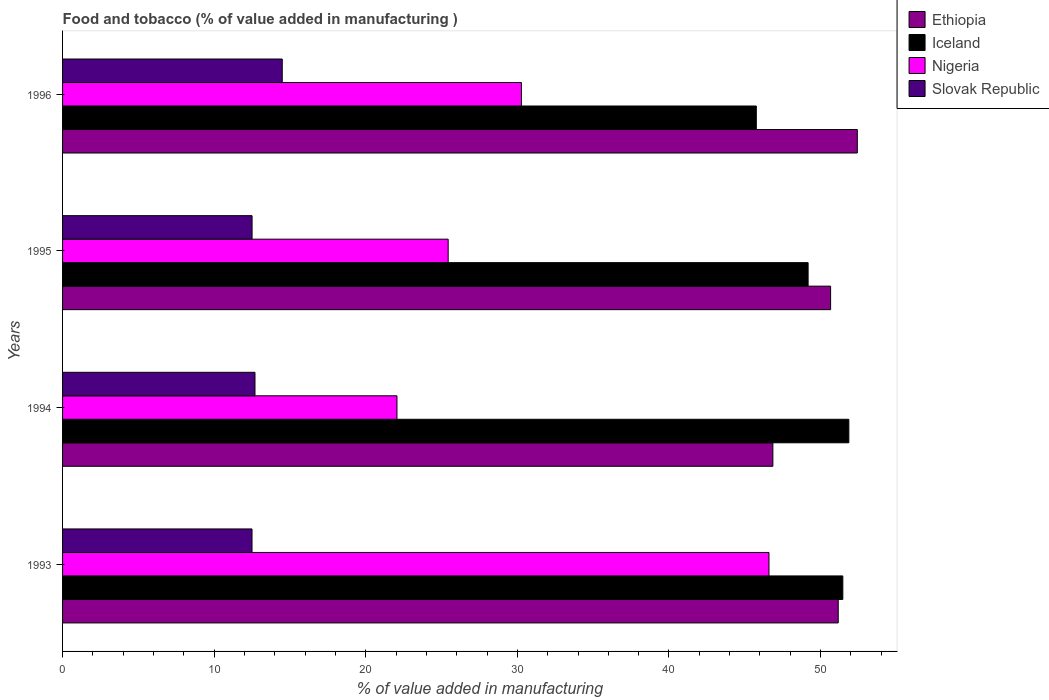How many different coloured bars are there?
Ensure brevity in your answer.  4. Are the number of bars per tick equal to the number of legend labels?
Offer a terse response. Yes. Are the number of bars on each tick of the Y-axis equal?
Keep it short and to the point. Yes. In how many cases, is the number of bars for a given year not equal to the number of legend labels?
Your answer should be compact. 0. What is the value added in manufacturing food and tobacco in Iceland in 1995?
Your answer should be compact. 49.18. Across all years, what is the maximum value added in manufacturing food and tobacco in Slovak Republic?
Provide a short and direct response. 14.49. Across all years, what is the minimum value added in manufacturing food and tobacco in Slovak Republic?
Offer a terse response. 12.5. In which year was the value added in manufacturing food and tobacco in Iceland maximum?
Ensure brevity in your answer.  1994. In which year was the value added in manufacturing food and tobacco in Iceland minimum?
Make the answer very short. 1996. What is the total value added in manufacturing food and tobacco in Nigeria in the graph?
Your answer should be compact. 124.35. What is the difference between the value added in manufacturing food and tobacco in Iceland in 1993 and that in 1996?
Offer a very short reply. 5.71. What is the difference between the value added in manufacturing food and tobacco in Nigeria in 1993 and the value added in manufacturing food and tobacco in Iceland in 1995?
Your answer should be compact. -2.58. What is the average value added in manufacturing food and tobacco in Ethiopia per year?
Your response must be concise. 50.27. In the year 1994, what is the difference between the value added in manufacturing food and tobacco in Nigeria and value added in manufacturing food and tobacco in Ethiopia?
Provide a short and direct response. -24.79. What is the ratio of the value added in manufacturing food and tobacco in Nigeria in 1995 to that in 1996?
Your answer should be very brief. 0.84. Is the value added in manufacturing food and tobacco in Slovak Republic in 1994 less than that in 1996?
Give a very brief answer. Yes. What is the difference between the highest and the second highest value added in manufacturing food and tobacco in Nigeria?
Keep it short and to the point. 16.33. What is the difference between the highest and the lowest value added in manufacturing food and tobacco in Slovak Republic?
Your answer should be compact. 1.99. In how many years, is the value added in manufacturing food and tobacco in Ethiopia greater than the average value added in manufacturing food and tobacco in Ethiopia taken over all years?
Ensure brevity in your answer.  3. What does the 1st bar from the top in 1995 represents?
Your answer should be compact. Slovak Republic. What does the 3rd bar from the bottom in 1996 represents?
Provide a succinct answer. Nigeria. Is it the case that in every year, the sum of the value added in manufacturing food and tobacco in Ethiopia and value added in manufacturing food and tobacco in Nigeria is greater than the value added in manufacturing food and tobacco in Slovak Republic?
Make the answer very short. Yes. How many bars are there?
Provide a succinct answer. 16. Are the values on the major ticks of X-axis written in scientific E-notation?
Ensure brevity in your answer.  No. What is the title of the graph?
Offer a terse response. Food and tobacco (% of value added in manufacturing ). What is the label or title of the X-axis?
Your answer should be compact. % of value added in manufacturing. What is the label or title of the Y-axis?
Your answer should be very brief. Years. What is the % of value added in manufacturing of Ethiopia in 1993?
Your answer should be compact. 51.16. What is the % of value added in manufacturing in Iceland in 1993?
Offer a very short reply. 51.47. What is the % of value added in manufacturing of Nigeria in 1993?
Provide a succinct answer. 46.6. What is the % of value added in manufacturing of Slovak Republic in 1993?
Your answer should be very brief. 12.5. What is the % of value added in manufacturing of Ethiopia in 1994?
Give a very brief answer. 46.85. What is the % of value added in manufacturing of Iceland in 1994?
Make the answer very short. 51.86. What is the % of value added in manufacturing in Nigeria in 1994?
Provide a short and direct response. 22.06. What is the % of value added in manufacturing in Slovak Republic in 1994?
Your response must be concise. 12.69. What is the % of value added in manufacturing of Ethiopia in 1995?
Your response must be concise. 50.66. What is the % of value added in manufacturing in Iceland in 1995?
Ensure brevity in your answer.  49.18. What is the % of value added in manufacturing of Nigeria in 1995?
Offer a very short reply. 25.43. What is the % of value added in manufacturing in Slovak Republic in 1995?
Provide a short and direct response. 12.5. What is the % of value added in manufacturing of Ethiopia in 1996?
Keep it short and to the point. 52.42. What is the % of value added in manufacturing in Iceland in 1996?
Your answer should be compact. 45.76. What is the % of value added in manufacturing of Nigeria in 1996?
Offer a terse response. 30.27. What is the % of value added in manufacturing in Slovak Republic in 1996?
Provide a succinct answer. 14.49. Across all years, what is the maximum % of value added in manufacturing in Ethiopia?
Offer a terse response. 52.42. Across all years, what is the maximum % of value added in manufacturing of Iceland?
Give a very brief answer. 51.86. Across all years, what is the maximum % of value added in manufacturing in Nigeria?
Make the answer very short. 46.6. Across all years, what is the maximum % of value added in manufacturing of Slovak Republic?
Your answer should be very brief. 14.49. Across all years, what is the minimum % of value added in manufacturing of Ethiopia?
Give a very brief answer. 46.85. Across all years, what is the minimum % of value added in manufacturing in Iceland?
Offer a very short reply. 45.76. Across all years, what is the minimum % of value added in manufacturing in Nigeria?
Provide a succinct answer. 22.06. Across all years, what is the minimum % of value added in manufacturing of Slovak Republic?
Keep it short and to the point. 12.5. What is the total % of value added in manufacturing of Ethiopia in the graph?
Your response must be concise. 201.1. What is the total % of value added in manufacturing in Iceland in the graph?
Make the answer very short. 198.27. What is the total % of value added in manufacturing of Nigeria in the graph?
Your response must be concise. 124.35. What is the total % of value added in manufacturing of Slovak Republic in the graph?
Ensure brevity in your answer.  52.18. What is the difference between the % of value added in manufacturing in Ethiopia in 1993 and that in 1994?
Provide a succinct answer. 4.31. What is the difference between the % of value added in manufacturing of Iceland in 1993 and that in 1994?
Your answer should be very brief. -0.4. What is the difference between the % of value added in manufacturing in Nigeria in 1993 and that in 1994?
Your response must be concise. 24.54. What is the difference between the % of value added in manufacturing of Slovak Republic in 1993 and that in 1994?
Offer a very short reply. -0.2. What is the difference between the % of value added in manufacturing in Ethiopia in 1993 and that in 1995?
Offer a terse response. 0.5. What is the difference between the % of value added in manufacturing in Iceland in 1993 and that in 1995?
Give a very brief answer. 2.29. What is the difference between the % of value added in manufacturing in Nigeria in 1993 and that in 1995?
Provide a succinct answer. 21.16. What is the difference between the % of value added in manufacturing in Slovak Republic in 1993 and that in 1995?
Ensure brevity in your answer.  -0. What is the difference between the % of value added in manufacturing in Ethiopia in 1993 and that in 1996?
Provide a succinct answer. -1.26. What is the difference between the % of value added in manufacturing of Iceland in 1993 and that in 1996?
Give a very brief answer. 5.71. What is the difference between the % of value added in manufacturing of Nigeria in 1993 and that in 1996?
Your answer should be very brief. 16.33. What is the difference between the % of value added in manufacturing of Slovak Republic in 1993 and that in 1996?
Give a very brief answer. -1.99. What is the difference between the % of value added in manufacturing of Ethiopia in 1994 and that in 1995?
Give a very brief answer. -3.81. What is the difference between the % of value added in manufacturing of Iceland in 1994 and that in 1995?
Provide a succinct answer. 2.69. What is the difference between the % of value added in manufacturing in Nigeria in 1994 and that in 1995?
Keep it short and to the point. -3.38. What is the difference between the % of value added in manufacturing of Slovak Republic in 1994 and that in 1995?
Your answer should be very brief. 0.19. What is the difference between the % of value added in manufacturing of Ethiopia in 1994 and that in 1996?
Provide a succinct answer. -5.57. What is the difference between the % of value added in manufacturing of Iceland in 1994 and that in 1996?
Ensure brevity in your answer.  6.1. What is the difference between the % of value added in manufacturing of Nigeria in 1994 and that in 1996?
Provide a short and direct response. -8.21. What is the difference between the % of value added in manufacturing in Slovak Republic in 1994 and that in 1996?
Your answer should be compact. -1.8. What is the difference between the % of value added in manufacturing of Ethiopia in 1995 and that in 1996?
Ensure brevity in your answer.  -1.76. What is the difference between the % of value added in manufacturing in Iceland in 1995 and that in 1996?
Offer a very short reply. 3.42. What is the difference between the % of value added in manufacturing of Nigeria in 1995 and that in 1996?
Keep it short and to the point. -4.83. What is the difference between the % of value added in manufacturing of Slovak Republic in 1995 and that in 1996?
Offer a very short reply. -1.99. What is the difference between the % of value added in manufacturing in Ethiopia in 1993 and the % of value added in manufacturing in Iceland in 1994?
Your response must be concise. -0.7. What is the difference between the % of value added in manufacturing in Ethiopia in 1993 and the % of value added in manufacturing in Nigeria in 1994?
Your response must be concise. 29.11. What is the difference between the % of value added in manufacturing in Ethiopia in 1993 and the % of value added in manufacturing in Slovak Republic in 1994?
Make the answer very short. 38.47. What is the difference between the % of value added in manufacturing in Iceland in 1993 and the % of value added in manufacturing in Nigeria in 1994?
Your answer should be very brief. 29.41. What is the difference between the % of value added in manufacturing in Iceland in 1993 and the % of value added in manufacturing in Slovak Republic in 1994?
Your response must be concise. 38.77. What is the difference between the % of value added in manufacturing of Nigeria in 1993 and the % of value added in manufacturing of Slovak Republic in 1994?
Ensure brevity in your answer.  33.9. What is the difference between the % of value added in manufacturing in Ethiopia in 1993 and the % of value added in manufacturing in Iceland in 1995?
Give a very brief answer. 1.99. What is the difference between the % of value added in manufacturing of Ethiopia in 1993 and the % of value added in manufacturing of Nigeria in 1995?
Your answer should be compact. 25.73. What is the difference between the % of value added in manufacturing in Ethiopia in 1993 and the % of value added in manufacturing in Slovak Republic in 1995?
Keep it short and to the point. 38.66. What is the difference between the % of value added in manufacturing in Iceland in 1993 and the % of value added in manufacturing in Nigeria in 1995?
Your response must be concise. 26.03. What is the difference between the % of value added in manufacturing in Iceland in 1993 and the % of value added in manufacturing in Slovak Republic in 1995?
Give a very brief answer. 38.97. What is the difference between the % of value added in manufacturing of Nigeria in 1993 and the % of value added in manufacturing of Slovak Republic in 1995?
Keep it short and to the point. 34.1. What is the difference between the % of value added in manufacturing in Ethiopia in 1993 and the % of value added in manufacturing in Iceland in 1996?
Your response must be concise. 5.4. What is the difference between the % of value added in manufacturing of Ethiopia in 1993 and the % of value added in manufacturing of Nigeria in 1996?
Your answer should be very brief. 20.9. What is the difference between the % of value added in manufacturing of Ethiopia in 1993 and the % of value added in manufacturing of Slovak Republic in 1996?
Your answer should be very brief. 36.67. What is the difference between the % of value added in manufacturing in Iceland in 1993 and the % of value added in manufacturing in Nigeria in 1996?
Your answer should be compact. 21.2. What is the difference between the % of value added in manufacturing in Iceland in 1993 and the % of value added in manufacturing in Slovak Republic in 1996?
Offer a very short reply. 36.98. What is the difference between the % of value added in manufacturing of Nigeria in 1993 and the % of value added in manufacturing of Slovak Republic in 1996?
Your answer should be compact. 32.11. What is the difference between the % of value added in manufacturing of Ethiopia in 1994 and the % of value added in manufacturing of Iceland in 1995?
Offer a terse response. -2.32. What is the difference between the % of value added in manufacturing in Ethiopia in 1994 and the % of value added in manufacturing in Nigeria in 1995?
Offer a terse response. 21.42. What is the difference between the % of value added in manufacturing in Ethiopia in 1994 and the % of value added in manufacturing in Slovak Republic in 1995?
Make the answer very short. 34.35. What is the difference between the % of value added in manufacturing in Iceland in 1994 and the % of value added in manufacturing in Nigeria in 1995?
Offer a very short reply. 26.43. What is the difference between the % of value added in manufacturing of Iceland in 1994 and the % of value added in manufacturing of Slovak Republic in 1995?
Give a very brief answer. 39.36. What is the difference between the % of value added in manufacturing of Nigeria in 1994 and the % of value added in manufacturing of Slovak Republic in 1995?
Your answer should be very brief. 9.56. What is the difference between the % of value added in manufacturing in Ethiopia in 1994 and the % of value added in manufacturing in Iceland in 1996?
Keep it short and to the point. 1.09. What is the difference between the % of value added in manufacturing in Ethiopia in 1994 and the % of value added in manufacturing in Nigeria in 1996?
Give a very brief answer. 16.59. What is the difference between the % of value added in manufacturing of Ethiopia in 1994 and the % of value added in manufacturing of Slovak Republic in 1996?
Give a very brief answer. 32.36. What is the difference between the % of value added in manufacturing of Iceland in 1994 and the % of value added in manufacturing of Nigeria in 1996?
Your response must be concise. 21.6. What is the difference between the % of value added in manufacturing in Iceland in 1994 and the % of value added in manufacturing in Slovak Republic in 1996?
Your answer should be very brief. 37.37. What is the difference between the % of value added in manufacturing of Nigeria in 1994 and the % of value added in manufacturing of Slovak Republic in 1996?
Your response must be concise. 7.57. What is the difference between the % of value added in manufacturing of Ethiopia in 1995 and the % of value added in manufacturing of Iceland in 1996?
Your answer should be very brief. 4.9. What is the difference between the % of value added in manufacturing in Ethiopia in 1995 and the % of value added in manufacturing in Nigeria in 1996?
Provide a succinct answer. 20.4. What is the difference between the % of value added in manufacturing of Ethiopia in 1995 and the % of value added in manufacturing of Slovak Republic in 1996?
Make the answer very short. 36.17. What is the difference between the % of value added in manufacturing of Iceland in 1995 and the % of value added in manufacturing of Nigeria in 1996?
Offer a very short reply. 18.91. What is the difference between the % of value added in manufacturing in Iceland in 1995 and the % of value added in manufacturing in Slovak Republic in 1996?
Offer a terse response. 34.69. What is the difference between the % of value added in manufacturing in Nigeria in 1995 and the % of value added in manufacturing in Slovak Republic in 1996?
Your answer should be very brief. 10.94. What is the average % of value added in manufacturing of Ethiopia per year?
Keep it short and to the point. 50.27. What is the average % of value added in manufacturing in Iceland per year?
Make the answer very short. 49.57. What is the average % of value added in manufacturing in Nigeria per year?
Offer a very short reply. 31.09. What is the average % of value added in manufacturing in Slovak Republic per year?
Keep it short and to the point. 13.04. In the year 1993, what is the difference between the % of value added in manufacturing in Ethiopia and % of value added in manufacturing in Iceland?
Provide a succinct answer. -0.3. In the year 1993, what is the difference between the % of value added in manufacturing in Ethiopia and % of value added in manufacturing in Nigeria?
Your response must be concise. 4.57. In the year 1993, what is the difference between the % of value added in manufacturing of Ethiopia and % of value added in manufacturing of Slovak Republic?
Your answer should be compact. 38.67. In the year 1993, what is the difference between the % of value added in manufacturing of Iceland and % of value added in manufacturing of Nigeria?
Give a very brief answer. 4.87. In the year 1993, what is the difference between the % of value added in manufacturing of Iceland and % of value added in manufacturing of Slovak Republic?
Ensure brevity in your answer.  38.97. In the year 1993, what is the difference between the % of value added in manufacturing of Nigeria and % of value added in manufacturing of Slovak Republic?
Offer a terse response. 34.1. In the year 1994, what is the difference between the % of value added in manufacturing of Ethiopia and % of value added in manufacturing of Iceland?
Ensure brevity in your answer.  -5.01. In the year 1994, what is the difference between the % of value added in manufacturing of Ethiopia and % of value added in manufacturing of Nigeria?
Offer a very short reply. 24.79. In the year 1994, what is the difference between the % of value added in manufacturing of Ethiopia and % of value added in manufacturing of Slovak Republic?
Ensure brevity in your answer.  34.16. In the year 1994, what is the difference between the % of value added in manufacturing in Iceland and % of value added in manufacturing in Nigeria?
Offer a very short reply. 29.81. In the year 1994, what is the difference between the % of value added in manufacturing in Iceland and % of value added in manufacturing in Slovak Republic?
Offer a very short reply. 39.17. In the year 1994, what is the difference between the % of value added in manufacturing in Nigeria and % of value added in manufacturing in Slovak Republic?
Keep it short and to the point. 9.37. In the year 1995, what is the difference between the % of value added in manufacturing in Ethiopia and % of value added in manufacturing in Iceland?
Provide a short and direct response. 1.48. In the year 1995, what is the difference between the % of value added in manufacturing of Ethiopia and % of value added in manufacturing of Nigeria?
Offer a terse response. 25.23. In the year 1995, what is the difference between the % of value added in manufacturing in Ethiopia and % of value added in manufacturing in Slovak Republic?
Keep it short and to the point. 38.16. In the year 1995, what is the difference between the % of value added in manufacturing in Iceland and % of value added in manufacturing in Nigeria?
Your answer should be compact. 23.74. In the year 1995, what is the difference between the % of value added in manufacturing in Iceland and % of value added in manufacturing in Slovak Republic?
Your response must be concise. 36.68. In the year 1995, what is the difference between the % of value added in manufacturing in Nigeria and % of value added in manufacturing in Slovak Republic?
Your response must be concise. 12.93. In the year 1996, what is the difference between the % of value added in manufacturing in Ethiopia and % of value added in manufacturing in Iceland?
Offer a very short reply. 6.66. In the year 1996, what is the difference between the % of value added in manufacturing in Ethiopia and % of value added in manufacturing in Nigeria?
Ensure brevity in your answer.  22.16. In the year 1996, what is the difference between the % of value added in manufacturing in Ethiopia and % of value added in manufacturing in Slovak Republic?
Keep it short and to the point. 37.93. In the year 1996, what is the difference between the % of value added in manufacturing of Iceland and % of value added in manufacturing of Nigeria?
Your answer should be very brief. 15.49. In the year 1996, what is the difference between the % of value added in manufacturing in Iceland and % of value added in manufacturing in Slovak Republic?
Your answer should be very brief. 31.27. In the year 1996, what is the difference between the % of value added in manufacturing of Nigeria and % of value added in manufacturing of Slovak Republic?
Ensure brevity in your answer.  15.77. What is the ratio of the % of value added in manufacturing in Ethiopia in 1993 to that in 1994?
Provide a succinct answer. 1.09. What is the ratio of the % of value added in manufacturing in Nigeria in 1993 to that in 1994?
Offer a very short reply. 2.11. What is the ratio of the % of value added in manufacturing in Slovak Republic in 1993 to that in 1994?
Provide a short and direct response. 0.98. What is the ratio of the % of value added in manufacturing of Ethiopia in 1993 to that in 1995?
Ensure brevity in your answer.  1.01. What is the ratio of the % of value added in manufacturing in Iceland in 1993 to that in 1995?
Provide a succinct answer. 1.05. What is the ratio of the % of value added in manufacturing in Nigeria in 1993 to that in 1995?
Your response must be concise. 1.83. What is the ratio of the % of value added in manufacturing of Iceland in 1993 to that in 1996?
Provide a short and direct response. 1.12. What is the ratio of the % of value added in manufacturing in Nigeria in 1993 to that in 1996?
Make the answer very short. 1.54. What is the ratio of the % of value added in manufacturing of Slovak Republic in 1993 to that in 1996?
Offer a very short reply. 0.86. What is the ratio of the % of value added in manufacturing in Ethiopia in 1994 to that in 1995?
Your answer should be compact. 0.92. What is the ratio of the % of value added in manufacturing of Iceland in 1994 to that in 1995?
Keep it short and to the point. 1.05. What is the ratio of the % of value added in manufacturing in Nigeria in 1994 to that in 1995?
Make the answer very short. 0.87. What is the ratio of the % of value added in manufacturing of Slovak Republic in 1994 to that in 1995?
Offer a terse response. 1.02. What is the ratio of the % of value added in manufacturing of Ethiopia in 1994 to that in 1996?
Your answer should be very brief. 0.89. What is the ratio of the % of value added in manufacturing of Iceland in 1994 to that in 1996?
Ensure brevity in your answer.  1.13. What is the ratio of the % of value added in manufacturing in Nigeria in 1994 to that in 1996?
Provide a succinct answer. 0.73. What is the ratio of the % of value added in manufacturing in Slovak Republic in 1994 to that in 1996?
Offer a very short reply. 0.88. What is the ratio of the % of value added in manufacturing in Ethiopia in 1995 to that in 1996?
Offer a terse response. 0.97. What is the ratio of the % of value added in manufacturing in Iceland in 1995 to that in 1996?
Offer a very short reply. 1.07. What is the ratio of the % of value added in manufacturing in Nigeria in 1995 to that in 1996?
Give a very brief answer. 0.84. What is the ratio of the % of value added in manufacturing in Slovak Republic in 1995 to that in 1996?
Your response must be concise. 0.86. What is the difference between the highest and the second highest % of value added in manufacturing of Ethiopia?
Make the answer very short. 1.26. What is the difference between the highest and the second highest % of value added in manufacturing of Iceland?
Make the answer very short. 0.4. What is the difference between the highest and the second highest % of value added in manufacturing of Nigeria?
Offer a very short reply. 16.33. What is the difference between the highest and the second highest % of value added in manufacturing in Slovak Republic?
Ensure brevity in your answer.  1.8. What is the difference between the highest and the lowest % of value added in manufacturing in Ethiopia?
Offer a terse response. 5.57. What is the difference between the highest and the lowest % of value added in manufacturing of Iceland?
Make the answer very short. 6.1. What is the difference between the highest and the lowest % of value added in manufacturing in Nigeria?
Provide a succinct answer. 24.54. What is the difference between the highest and the lowest % of value added in manufacturing in Slovak Republic?
Provide a short and direct response. 1.99. 